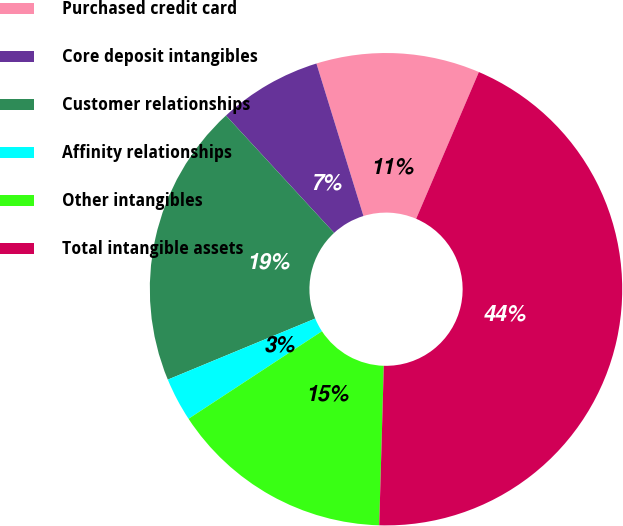Convert chart. <chart><loc_0><loc_0><loc_500><loc_500><pie_chart><fcel>Purchased credit card<fcel>Core deposit intangibles<fcel>Customer relationships<fcel>Affinity relationships<fcel>Other intangibles<fcel>Total intangible assets<nl><fcel>11.19%<fcel>7.09%<fcel>19.4%<fcel>2.99%<fcel>15.3%<fcel>44.03%<nl></chart> 